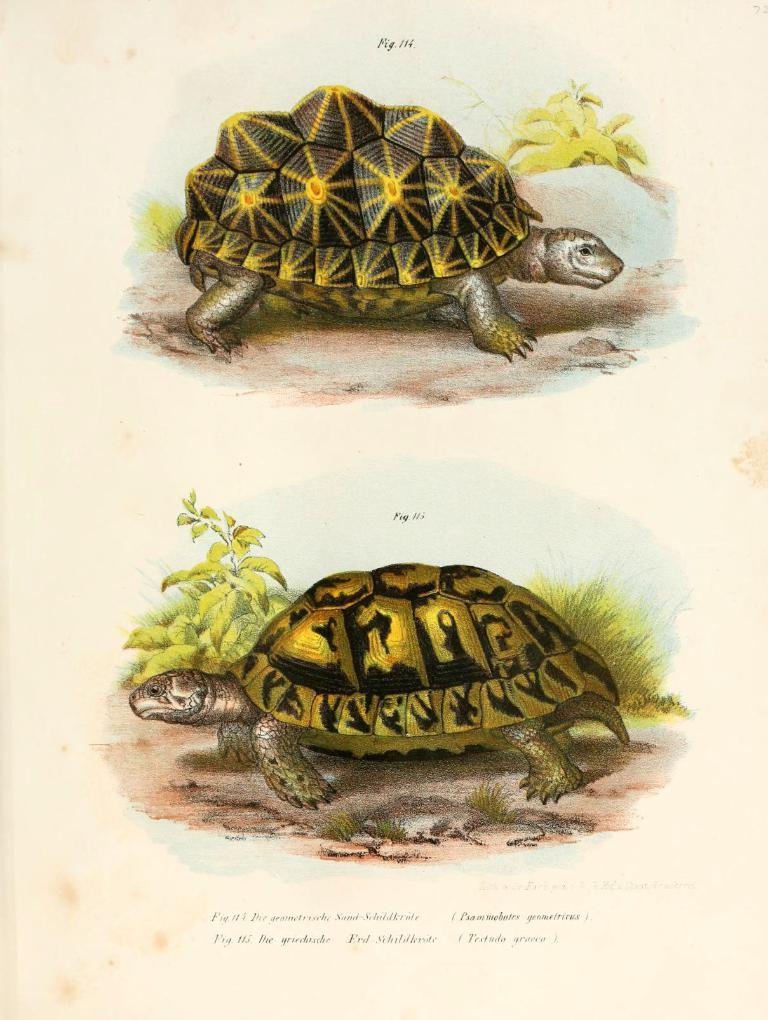What type of animals are depicted on the paper in the image? There are images of tortoises on the paper. How many images of tortoises are on the paper? There are two images of tortoises on the paper. What colors are the tortoises in the images? The tortoises are in green and black colors. What else can be found on the paper besides the tortoise images? There is text on the paper. Can you tell me how many cattle are grazing near the lake in the image? There is no lake or cattle present in the image; it features images of tortoises and text on a paper. What type of laborer is working on the paper in the image? There is no laborer present in the image; it only shows images of tortoises and text on a paper. 